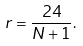Convert formula to latex. <formula><loc_0><loc_0><loc_500><loc_500>r = \frac { 2 4 } { N + 1 } .</formula> 